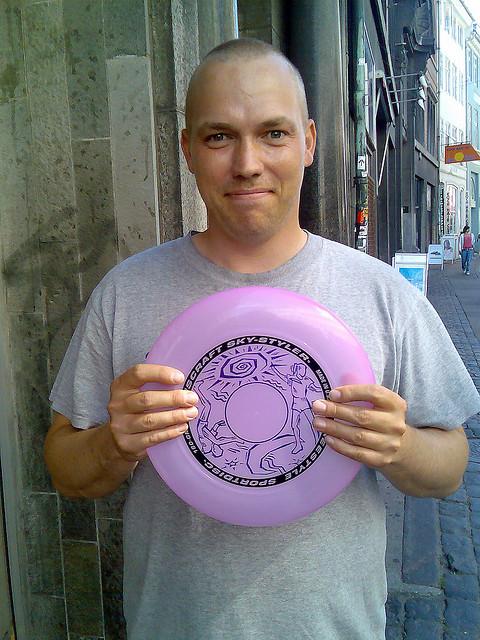Is the man smiling?
Write a very short answer. Yes. Is the man wearing any rings on his fingers?
Keep it brief. No. What is the man holding in his hands?
Short answer required. Frisbee. 